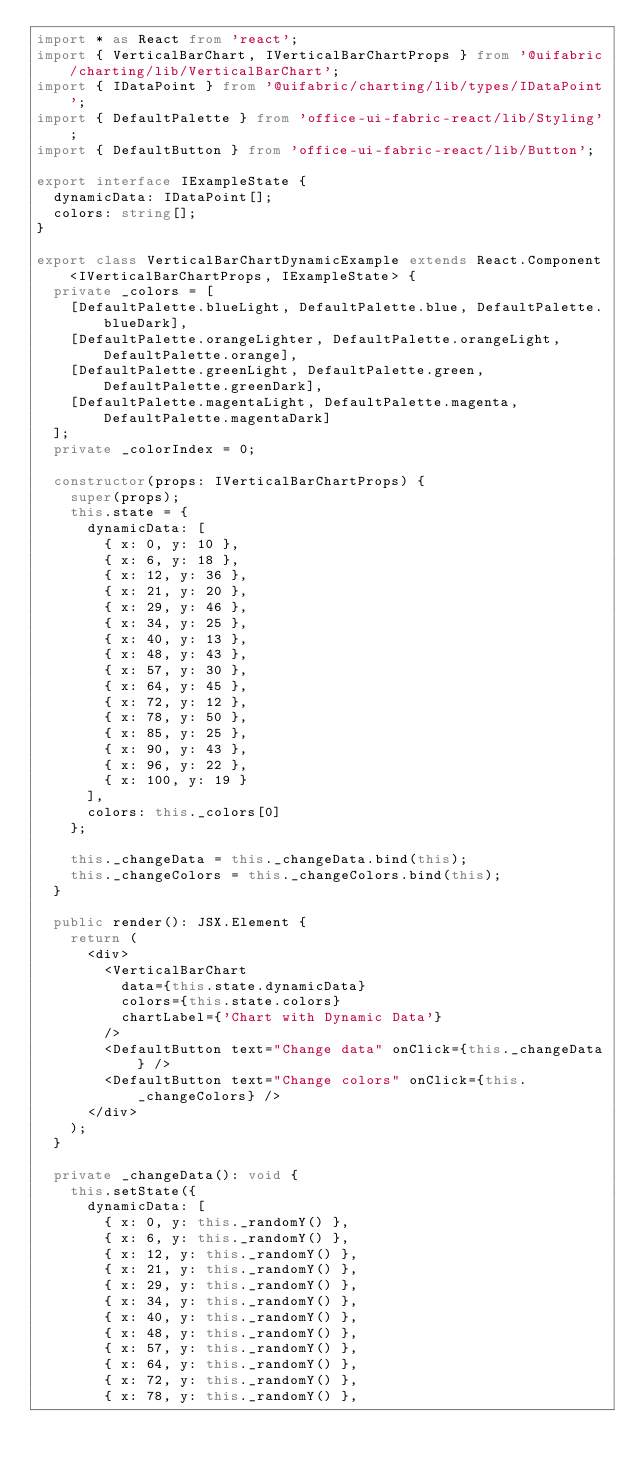<code> <loc_0><loc_0><loc_500><loc_500><_TypeScript_>import * as React from 'react';
import { VerticalBarChart, IVerticalBarChartProps } from '@uifabric/charting/lib/VerticalBarChart';
import { IDataPoint } from '@uifabric/charting/lib/types/IDataPoint';
import { DefaultPalette } from 'office-ui-fabric-react/lib/Styling';
import { DefaultButton } from 'office-ui-fabric-react/lib/Button';

export interface IExampleState {
  dynamicData: IDataPoint[];
  colors: string[];
}

export class VerticalBarChartDynamicExample extends React.Component<IVerticalBarChartProps, IExampleState> {
  private _colors = [
    [DefaultPalette.blueLight, DefaultPalette.blue, DefaultPalette.blueDark],
    [DefaultPalette.orangeLighter, DefaultPalette.orangeLight, DefaultPalette.orange],
    [DefaultPalette.greenLight, DefaultPalette.green, DefaultPalette.greenDark],
    [DefaultPalette.magentaLight, DefaultPalette.magenta, DefaultPalette.magentaDark]
  ];
  private _colorIndex = 0;

  constructor(props: IVerticalBarChartProps) {
    super(props);
    this.state = {
      dynamicData: [
        { x: 0, y: 10 },
        { x: 6, y: 18 },
        { x: 12, y: 36 },
        { x: 21, y: 20 },
        { x: 29, y: 46 },
        { x: 34, y: 25 },
        { x: 40, y: 13 },
        { x: 48, y: 43 },
        { x: 57, y: 30 },
        { x: 64, y: 45 },
        { x: 72, y: 12 },
        { x: 78, y: 50 },
        { x: 85, y: 25 },
        { x: 90, y: 43 },
        { x: 96, y: 22 },
        { x: 100, y: 19 }
      ],
      colors: this._colors[0]
    };

    this._changeData = this._changeData.bind(this);
    this._changeColors = this._changeColors.bind(this);
  }

  public render(): JSX.Element {
    return (
      <div>
        <VerticalBarChart
          data={this.state.dynamicData}
          colors={this.state.colors}
          chartLabel={'Chart with Dynamic Data'}
        />
        <DefaultButton text="Change data" onClick={this._changeData} />
        <DefaultButton text="Change colors" onClick={this._changeColors} />
      </div>
    );
  }

  private _changeData(): void {
    this.setState({
      dynamicData: [
        { x: 0, y: this._randomY() },
        { x: 6, y: this._randomY() },
        { x: 12, y: this._randomY() },
        { x: 21, y: this._randomY() },
        { x: 29, y: this._randomY() },
        { x: 34, y: this._randomY() },
        { x: 40, y: this._randomY() },
        { x: 48, y: this._randomY() },
        { x: 57, y: this._randomY() },
        { x: 64, y: this._randomY() },
        { x: 72, y: this._randomY() },
        { x: 78, y: this._randomY() },</code> 